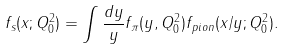Convert formula to latex. <formula><loc_0><loc_0><loc_500><loc_500>f _ { s } ( x ; Q ^ { 2 } _ { 0 } ) = \int \frac { d y } { y } f _ { \pi } ( y , Q ^ { 2 } _ { 0 } ) f _ { p i o n } ( x / y ; Q ^ { 2 } _ { 0 } ) .</formula> 